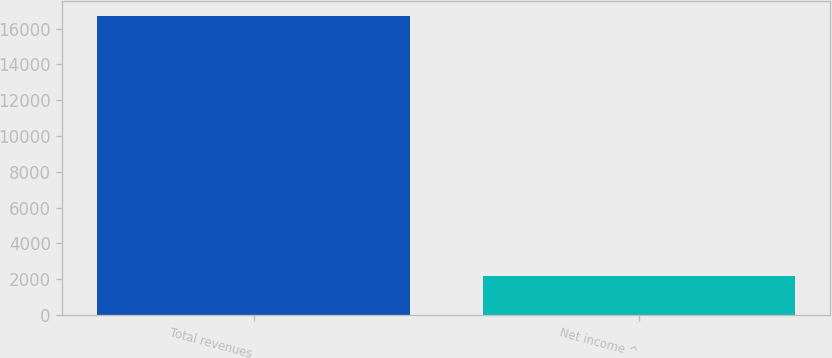Convert chart to OTSL. <chart><loc_0><loc_0><loc_500><loc_500><bar_chart><fcel>Total revenues<fcel>Net income ^<nl><fcel>16697<fcel>2201<nl></chart> 